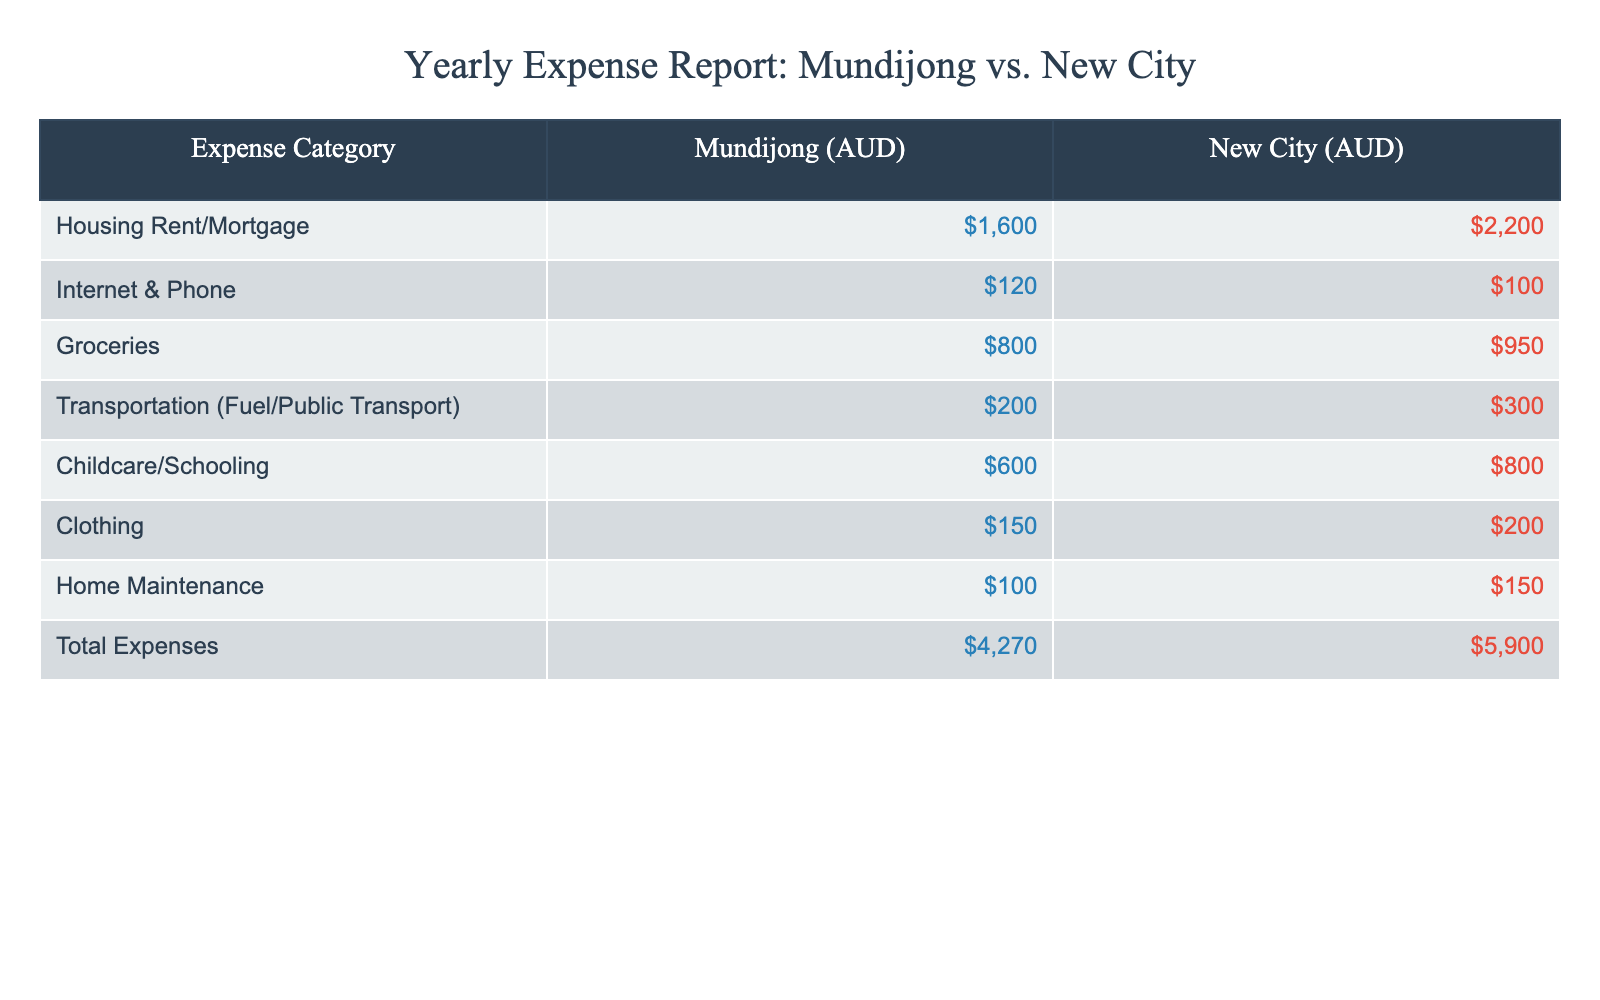What is the total expense in Mundijong? The total expenses in Mundijong are listed directly in the table. It shows $4,270 as the total expense for the year.
Answer: 4270 What is the difference in total expenses between Mundijong and the New City? To find the difference, subtract the total expenses in Mundijong ($4,270) from those in the New City ($5,900). The calculation gives $5,900 - $4,270 = $1,630.
Answer: 1630 Which category is the highest expense in both Mundijong and the New City? Looking at the table, the highest expense category for both locations is Housing Rent/Mortgage, which is $1,600 in Mundijong and $2,200 in the New City.
Answer: Housing Rent/Mortgage Is transportation more expensive in the New City compared to Mundijong? By comparing the expenses listed for Transportation, it costs $300 in the New City and $200 in Mundijong, which confirms that transportation is more expensive in the New City.
Answer: Yes What percentage of total expenses in Mundijong is allocated to groceries? To find the percentage, divide the groceries cost in Mundijong ($800) by the total expenses ($4,270), and multiply by 100. The calculation is ($800 / $4,270) * 100 = 18.7%.
Answer: 18.7% If we combine the expenses for Internet & Phone and Home Maintenance, what is the total for Mundijong? Adding the expenses for Internet & Phone ($120) and Home Maintenance ($100) gives a total of $120 + $100 = $220.
Answer: 220 What is the average expense per category in the New City? There are 8 expense categories in total. The total expense for the New City is $5,900. To find the average, divide $5,900 by 8 categories: $5,900 / 8 = $737.50.
Answer: 737.50 In which category does Mundijong save the most compared to the New City? By comparing costs, Mundijong saves the most in Housing, with $1,600 compared to $2,200 in the New City, resulting in a saving of $600.
Answer: Housing Rent/Mortgage What is the total of child-related expenses in Mundijong? The child-related expenses include Childcare/Schooling, which is listed as $600. Since this is the only child-related expense shown, $600 is the total.
Answer: 600 Is the sum of food-related expenses (Groceries) more than Childcare/Schooling in New City? The grocery expense in New City is $950, while the Childcare/Schooling expense is $800. $950 is greater than $800, confirming that food expenses exceed childcare costs.
Answer: Yes 